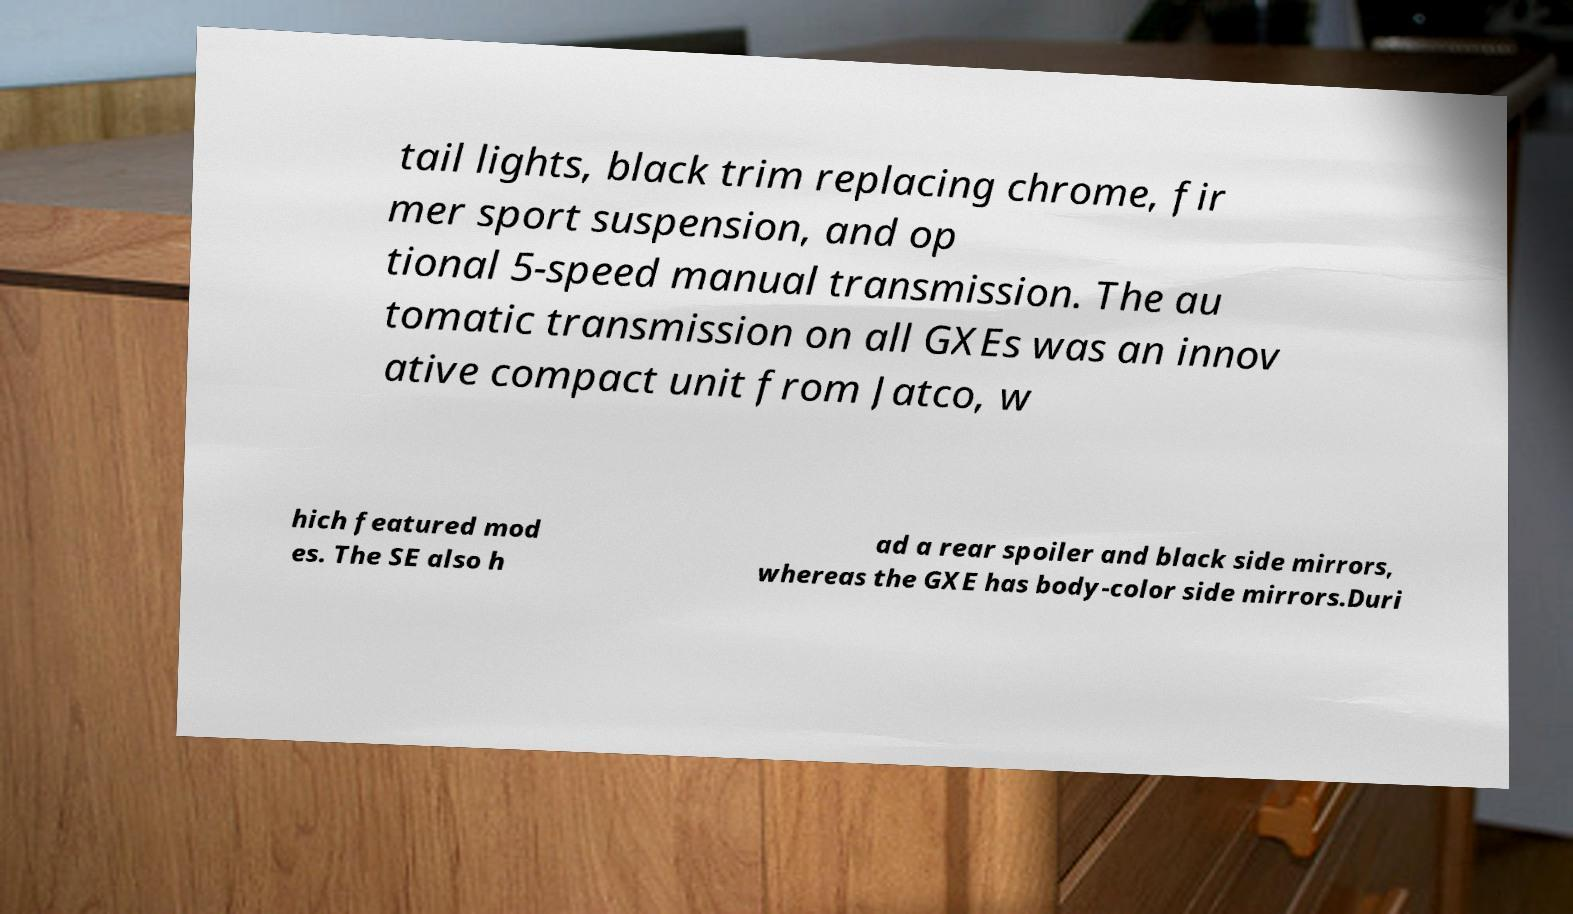Could you extract and type out the text from this image? tail lights, black trim replacing chrome, fir mer sport suspension, and op tional 5-speed manual transmission. The au tomatic transmission on all GXEs was an innov ative compact unit from Jatco, w hich featured mod es. The SE also h ad a rear spoiler and black side mirrors, whereas the GXE has body-color side mirrors.Duri 